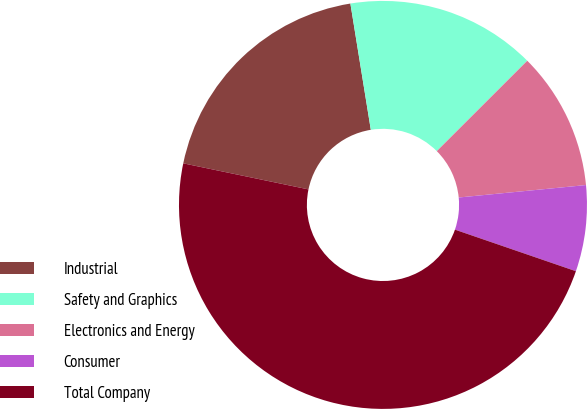Convert chart to OTSL. <chart><loc_0><loc_0><loc_500><loc_500><pie_chart><fcel>Industrial<fcel>Safety and Graphics<fcel>Electronics and Energy<fcel>Consumer<fcel>Total Company<nl><fcel>19.18%<fcel>15.06%<fcel>10.94%<fcel>6.82%<fcel>48.0%<nl></chart> 